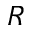Convert formula to latex. <formula><loc_0><loc_0><loc_500><loc_500>R</formula> 